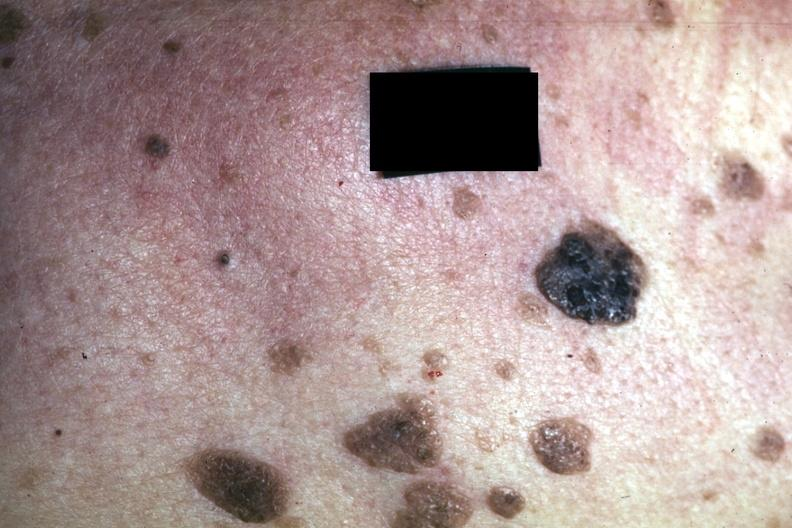where is this?
Answer the question using a single word or phrase. Skin 